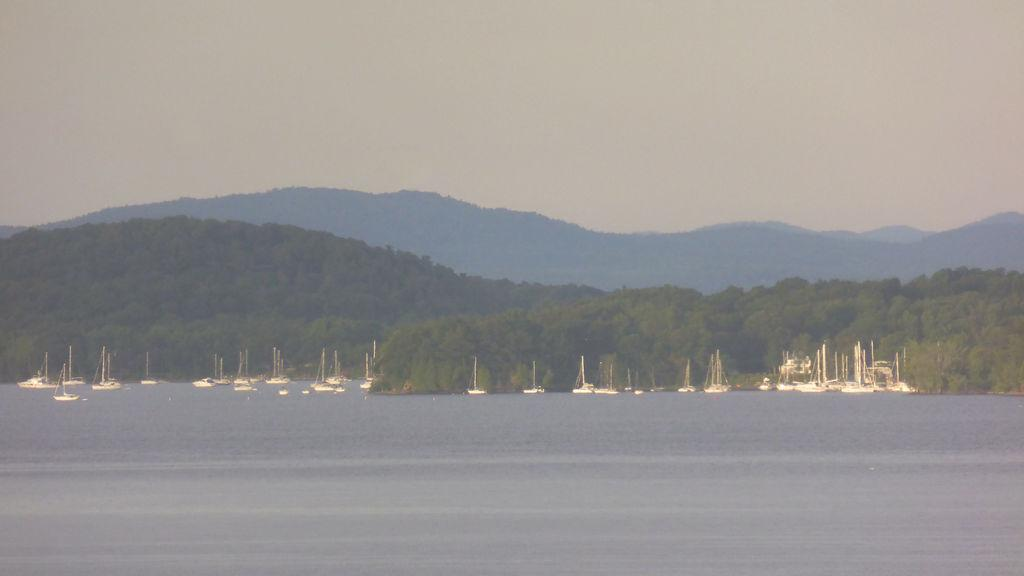What is on the water in the image? There are boats on the water in the image. What type of vegetation can be seen in the image? There are trees visible in the image. What geographical feature is present in the image? There are mountains in the image. What is visible in the background of the image? The sky is visible in the background of the image. How does the regret manifest itself in the image? There is no indication of regret in the image; it features boats on the water, trees, mountains, and the sky. Can you tell me how many people are dealing with death in the image? There is no mention of death in the image; it focuses on natural elements such as water, trees, mountains, and the sky. 